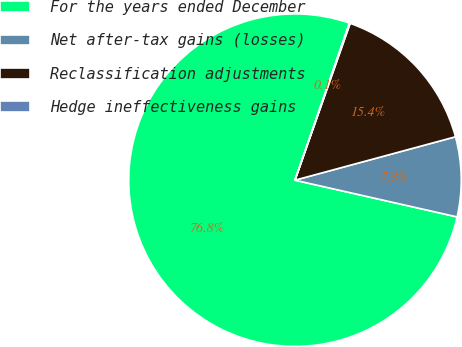Convert chart to OTSL. <chart><loc_0><loc_0><loc_500><loc_500><pie_chart><fcel>For the years ended December<fcel>Net after-tax gains (losses)<fcel>Reclassification adjustments<fcel>Hedge ineffectiveness gains<nl><fcel>76.76%<fcel>7.75%<fcel>15.41%<fcel>0.08%<nl></chart> 